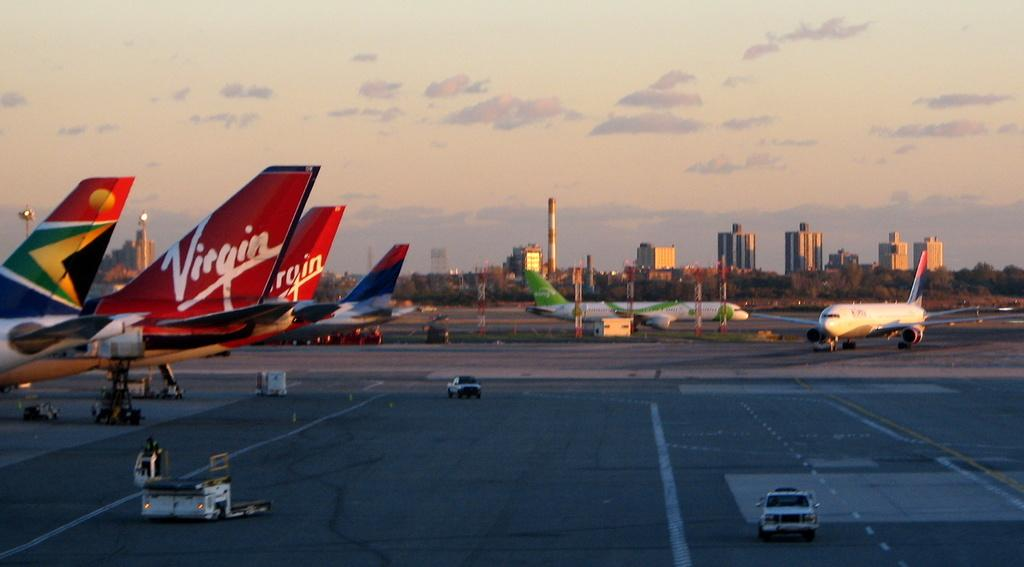<image>
Give a short and clear explanation of the subsequent image. A tarmac at sunset with Virgin airplanes parked. 